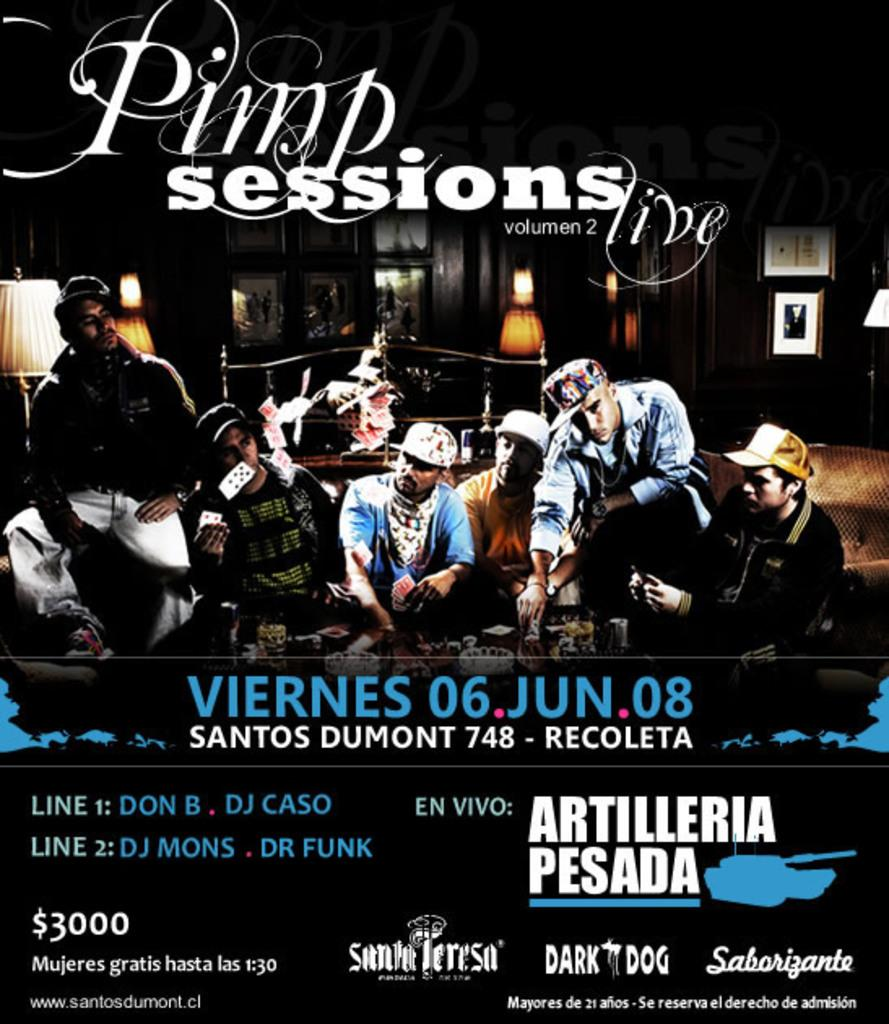<image>
Summarize the visual content of the image. A poster advertises the "Pimp Sessions," taking place on June 6, 2008. 